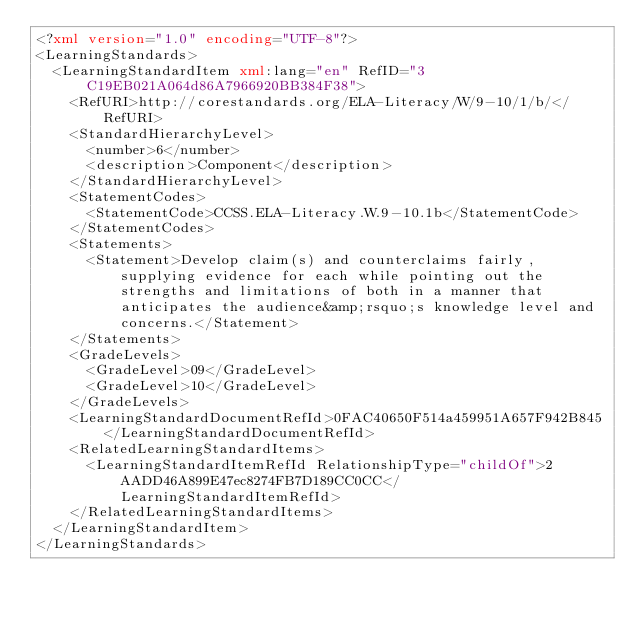Convert code to text. <code><loc_0><loc_0><loc_500><loc_500><_XML_><?xml version="1.0" encoding="UTF-8"?>
<LearningStandards>
  <LearningStandardItem xml:lang="en" RefID="3C19EB021A064d86A7966920BB384F38">
    <RefURI>http://corestandards.org/ELA-Literacy/W/9-10/1/b/</RefURI>
    <StandardHierarchyLevel>
      <number>6</number>
      <description>Component</description>
    </StandardHierarchyLevel>
    <StatementCodes>
      <StatementCode>CCSS.ELA-Literacy.W.9-10.1b</StatementCode>
    </StatementCodes>
    <Statements>
      <Statement>Develop claim(s) and counterclaims fairly, supplying evidence for each while pointing out the strengths and limitations of both in a manner that anticipates the audience&amp;rsquo;s knowledge level and concerns.</Statement>
    </Statements>
    <GradeLevels>
      <GradeLevel>09</GradeLevel>
      <GradeLevel>10</GradeLevel>
    </GradeLevels>
    <LearningStandardDocumentRefId>0FAC40650F514a459951A657F942B845</LearningStandardDocumentRefId>
    <RelatedLearningStandardItems>
      <LearningStandardItemRefId RelationshipType="childOf">2AADD46A899E47ec8274FB7D189CC0CC</LearningStandardItemRefId>
    </RelatedLearningStandardItems>
  </LearningStandardItem>
</LearningStandards>
</code> 